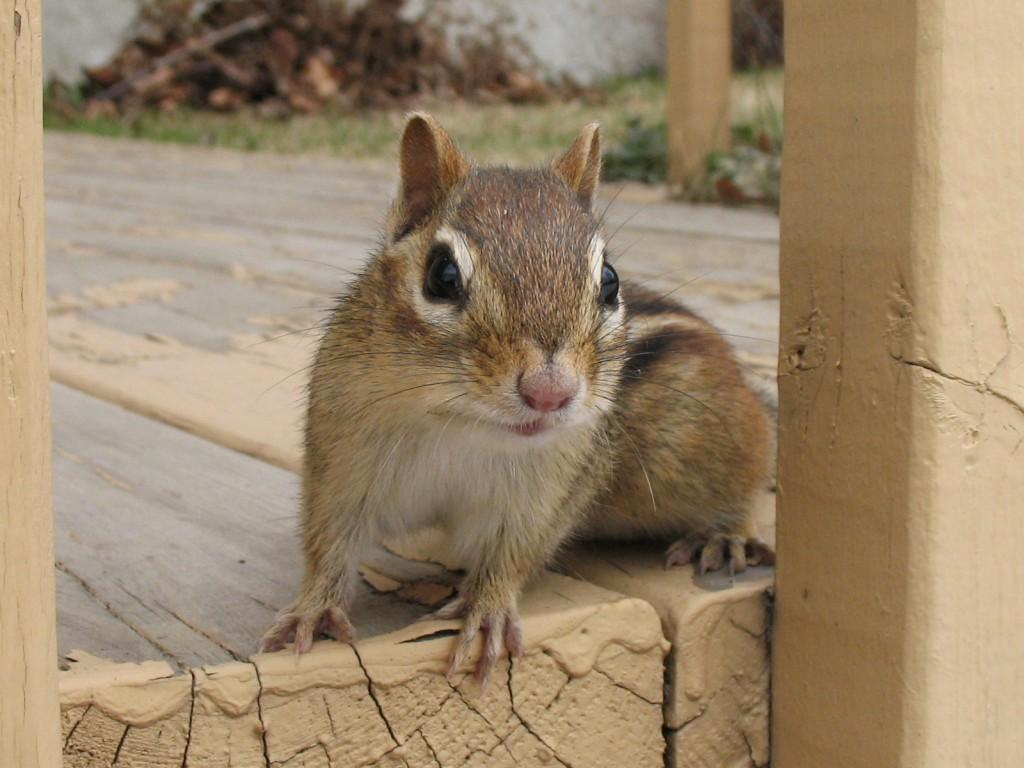What animal can be seen in the image? There is a squirrel in the image. Where is the squirrel located? The squirrel is sitting on the floor. What is the floor made of? The floor is made of wood. What can be seen in the background of the image? There are plants in the background of the image. What is to the left of the image? There is a pillar to the left of the image. Reasoning: Let's think step by step by following the provided facts step by step to create the conversation. We start by identifying the main subject in the image, which is the squirrel. Then, we describe its location and the material of the floor. Next, we mention the plants in the background and the presence of a pillar to the left of the image. Each question is designed to elicit a specific detail about the image that is known from the provided facts. Absurd Question/Answer: What type of eggs can be seen in the image? There are no eggs present in the image; it features a squirrel sitting on a wooden floor with plants in the background and a pillar to the left. Can you see a kitty playing with the squirrel in the image? There is no kitty present in the image; only the squirrel is visible. What type of eggs can be seen in the image? There are no eggs present in the image; it features a squirrel sitting on a wooden floor with plants in the background and a pillar to the left. Can you see a kitty playing with the squirrel in the image? There is no kitty present in the image; only the squirrel is visible. 